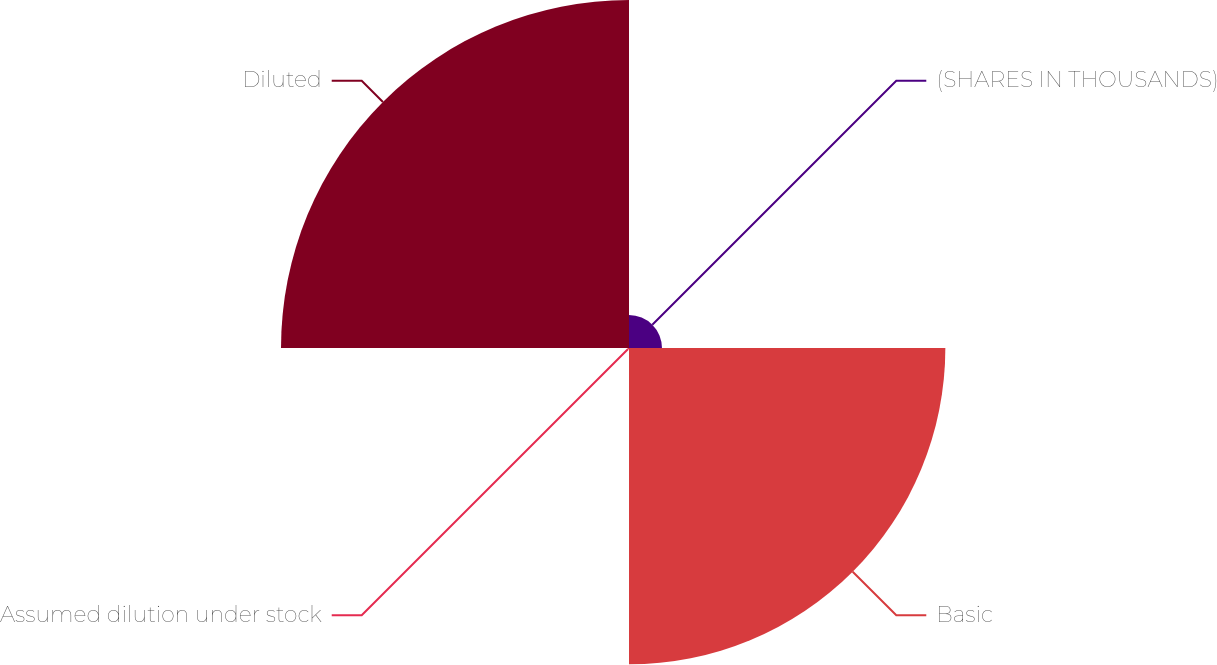Convert chart to OTSL. <chart><loc_0><loc_0><loc_500><loc_500><pie_chart><fcel>(SHARES IN THOUSANDS)<fcel>Basic<fcel>Assumed dilution under stock<fcel>Diluted<nl><fcel>4.72%<fcel>45.28%<fcel>0.19%<fcel>49.81%<nl></chart> 